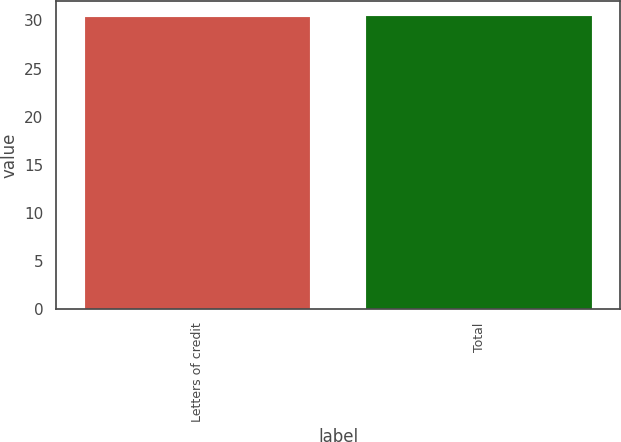Convert chart. <chart><loc_0><loc_0><loc_500><loc_500><bar_chart><fcel>Letters of credit<fcel>Total<nl><fcel>30.4<fcel>30.5<nl></chart> 